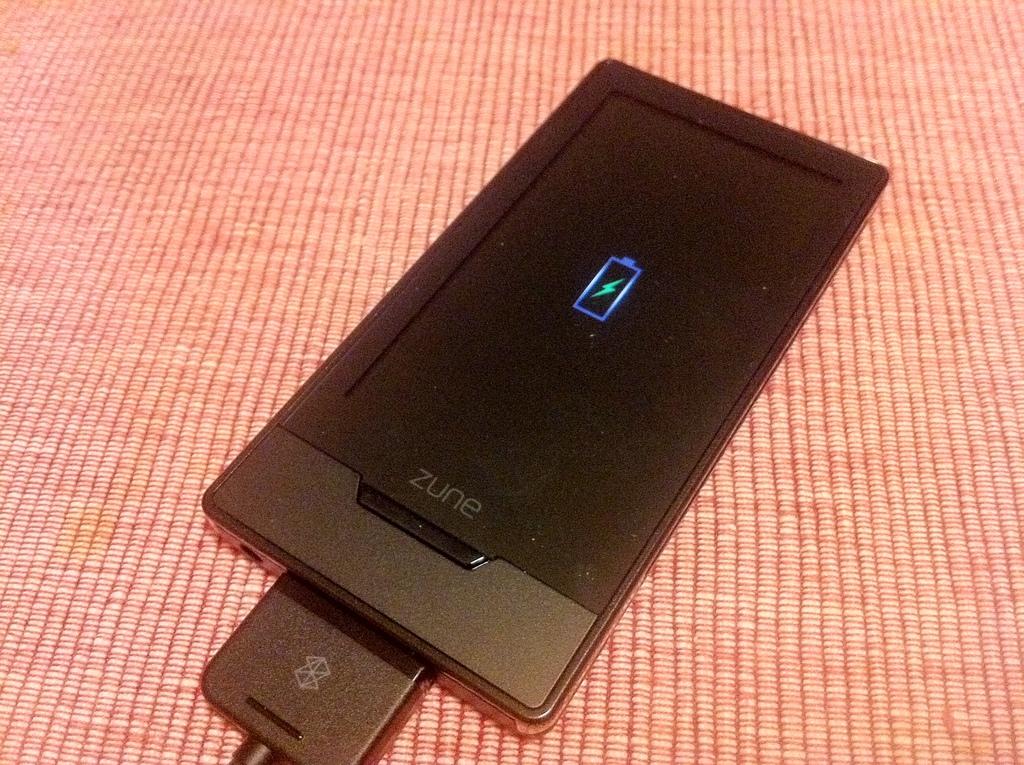Can you name the cellphone brand?
Your answer should be compact. Zune. 